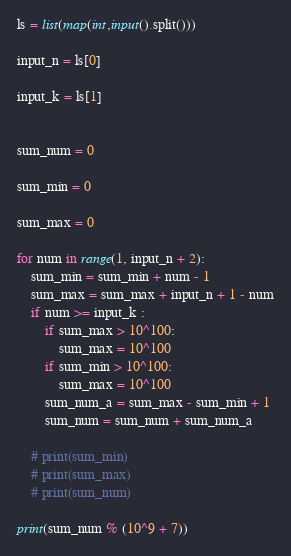Convert code to text. <code><loc_0><loc_0><loc_500><loc_500><_Python_>
ls = list(map(int,input().split()))

input_n = ls[0]

input_k = ls[1]


sum_num = 0

sum_min = 0

sum_max = 0

for num in range(1, input_n + 2):
    sum_min = sum_min + num - 1
    sum_max = sum_max + input_n + 1 - num
    if num >= input_k :
        if sum_max > 10^100:
            sum_max = 10^100
        if sum_min > 10^100:
            sum_max = 10^100
        sum_num_a = sum_max - sum_min + 1
        sum_num = sum_num + sum_num_a
    
    # print(sum_min)
    # print(sum_max)
    # print(sum_num)

print(sum_num % (10^9 + 7))

</code> 